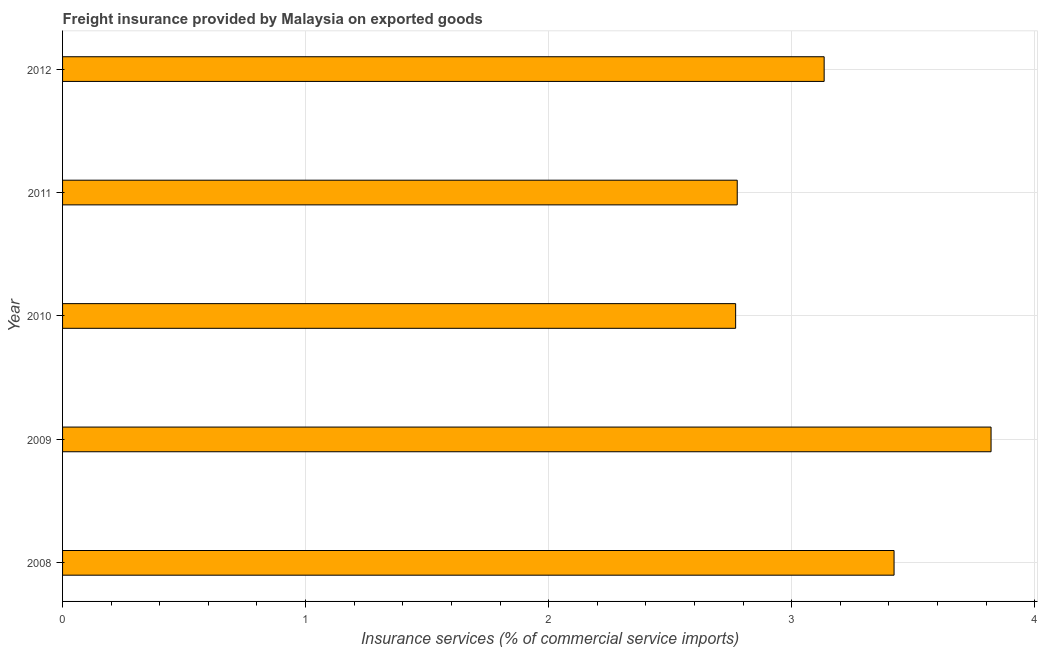Does the graph contain any zero values?
Provide a short and direct response. No. What is the title of the graph?
Give a very brief answer. Freight insurance provided by Malaysia on exported goods . What is the label or title of the X-axis?
Your answer should be compact. Insurance services (% of commercial service imports). What is the label or title of the Y-axis?
Give a very brief answer. Year. What is the freight insurance in 2009?
Ensure brevity in your answer.  3.82. Across all years, what is the maximum freight insurance?
Give a very brief answer. 3.82. Across all years, what is the minimum freight insurance?
Give a very brief answer. 2.77. In which year was the freight insurance minimum?
Provide a short and direct response. 2010. What is the sum of the freight insurance?
Offer a very short reply. 15.92. What is the difference between the freight insurance in 2008 and 2012?
Give a very brief answer. 0.29. What is the average freight insurance per year?
Your response must be concise. 3.18. What is the median freight insurance?
Keep it short and to the point. 3.13. In how many years, is the freight insurance greater than 2.6 %?
Offer a very short reply. 5. Do a majority of the years between 2010 and 2012 (inclusive) have freight insurance greater than 1.8 %?
Offer a terse response. Yes. What is the ratio of the freight insurance in 2008 to that in 2012?
Provide a short and direct response. 1.09. Is the freight insurance in 2008 less than that in 2009?
Provide a succinct answer. Yes. What is the difference between the highest and the second highest freight insurance?
Offer a very short reply. 0.4. Is the sum of the freight insurance in 2011 and 2012 greater than the maximum freight insurance across all years?
Provide a succinct answer. Yes. What is the difference between the highest and the lowest freight insurance?
Make the answer very short. 1.05. How many bars are there?
Your answer should be very brief. 5. Are all the bars in the graph horizontal?
Make the answer very short. Yes. How many years are there in the graph?
Your answer should be very brief. 5. What is the difference between two consecutive major ticks on the X-axis?
Make the answer very short. 1. Are the values on the major ticks of X-axis written in scientific E-notation?
Your answer should be compact. No. What is the Insurance services (% of commercial service imports) in 2008?
Provide a short and direct response. 3.42. What is the Insurance services (% of commercial service imports) of 2009?
Offer a very short reply. 3.82. What is the Insurance services (% of commercial service imports) in 2010?
Make the answer very short. 2.77. What is the Insurance services (% of commercial service imports) in 2011?
Offer a very short reply. 2.78. What is the Insurance services (% of commercial service imports) in 2012?
Ensure brevity in your answer.  3.13. What is the difference between the Insurance services (% of commercial service imports) in 2008 and 2009?
Keep it short and to the point. -0.4. What is the difference between the Insurance services (% of commercial service imports) in 2008 and 2010?
Ensure brevity in your answer.  0.65. What is the difference between the Insurance services (% of commercial service imports) in 2008 and 2011?
Provide a short and direct response. 0.65. What is the difference between the Insurance services (% of commercial service imports) in 2008 and 2012?
Make the answer very short. 0.29. What is the difference between the Insurance services (% of commercial service imports) in 2009 and 2010?
Offer a terse response. 1.05. What is the difference between the Insurance services (% of commercial service imports) in 2009 and 2011?
Offer a terse response. 1.04. What is the difference between the Insurance services (% of commercial service imports) in 2009 and 2012?
Offer a very short reply. 0.69. What is the difference between the Insurance services (% of commercial service imports) in 2010 and 2011?
Offer a terse response. -0.01. What is the difference between the Insurance services (% of commercial service imports) in 2010 and 2012?
Give a very brief answer. -0.36. What is the difference between the Insurance services (% of commercial service imports) in 2011 and 2012?
Your answer should be very brief. -0.36. What is the ratio of the Insurance services (% of commercial service imports) in 2008 to that in 2009?
Your answer should be compact. 0.9. What is the ratio of the Insurance services (% of commercial service imports) in 2008 to that in 2010?
Offer a very short reply. 1.24. What is the ratio of the Insurance services (% of commercial service imports) in 2008 to that in 2011?
Provide a short and direct response. 1.23. What is the ratio of the Insurance services (% of commercial service imports) in 2008 to that in 2012?
Your answer should be compact. 1.09. What is the ratio of the Insurance services (% of commercial service imports) in 2009 to that in 2010?
Offer a very short reply. 1.38. What is the ratio of the Insurance services (% of commercial service imports) in 2009 to that in 2011?
Ensure brevity in your answer.  1.38. What is the ratio of the Insurance services (% of commercial service imports) in 2009 to that in 2012?
Provide a succinct answer. 1.22. What is the ratio of the Insurance services (% of commercial service imports) in 2010 to that in 2012?
Your answer should be compact. 0.88. What is the ratio of the Insurance services (% of commercial service imports) in 2011 to that in 2012?
Provide a short and direct response. 0.89. 